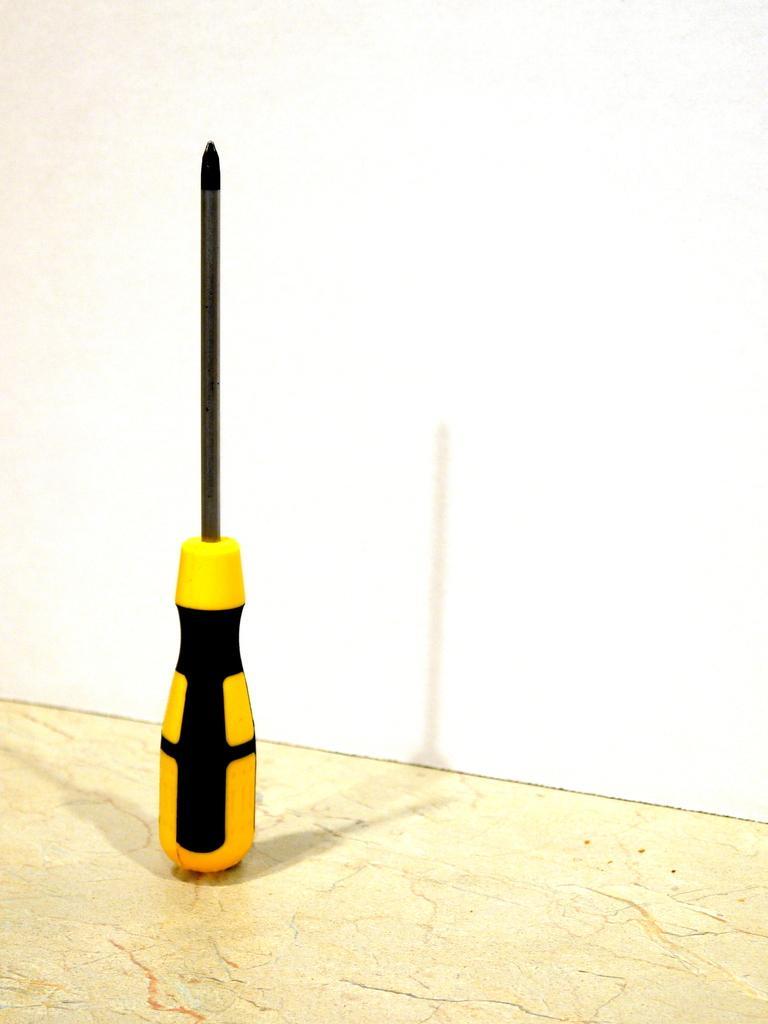Describe this image in one or two sentences. In this image I can see a screwdriver in yellow and black color. 